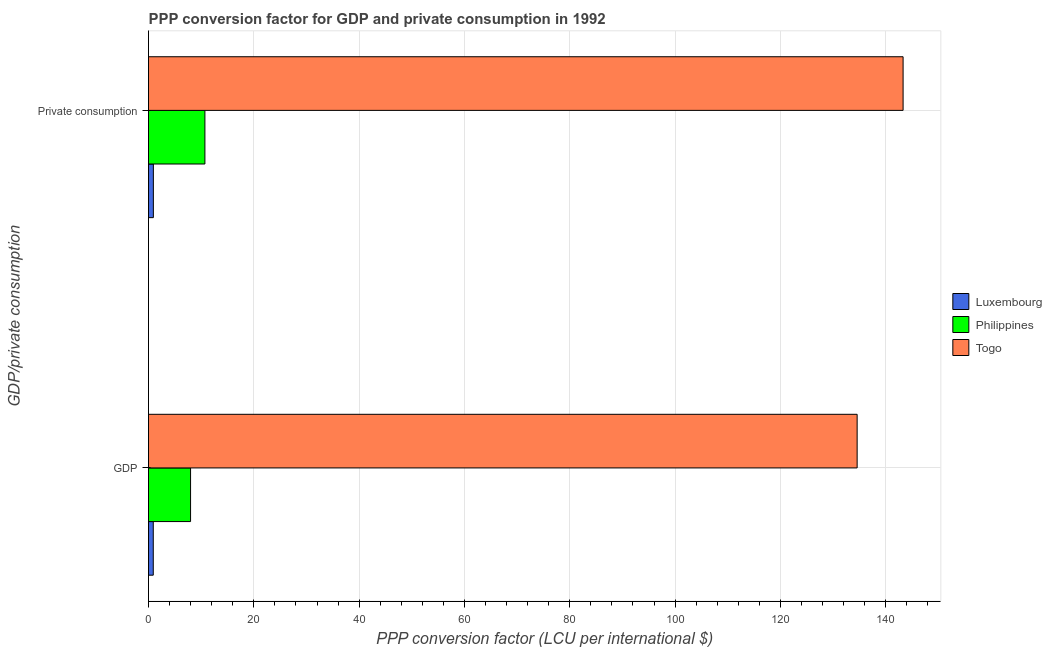How many different coloured bars are there?
Keep it short and to the point. 3. How many groups of bars are there?
Give a very brief answer. 2. Are the number of bars per tick equal to the number of legend labels?
Your response must be concise. Yes. How many bars are there on the 2nd tick from the top?
Your answer should be compact. 3. How many bars are there on the 2nd tick from the bottom?
Make the answer very short. 3. What is the label of the 2nd group of bars from the top?
Your response must be concise. GDP. What is the ppp conversion factor for gdp in Togo?
Keep it short and to the point. 134.57. Across all countries, what is the maximum ppp conversion factor for private consumption?
Make the answer very short. 143.3. Across all countries, what is the minimum ppp conversion factor for gdp?
Provide a short and direct response. 0.9. In which country was the ppp conversion factor for gdp maximum?
Offer a very short reply. Togo. In which country was the ppp conversion factor for gdp minimum?
Your answer should be very brief. Luxembourg. What is the total ppp conversion factor for gdp in the graph?
Ensure brevity in your answer.  143.46. What is the difference between the ppp conversion factor for gdp in Togo and that in Philippines?
Your answer should be compact. 126.59. What is the difference between the ppp conversion factor for gdp in Togo and the ppp conversion factor for private consumption in Philippines?
Keep it short and to the point. 123.86. What is the average ppp conversion factor for gdp per country?
Your answer should be very brief. 47.82. What is the difference between the ppp conversion factor for private consumption and ppp conversion factor for gdp in Philippines?
Give a very brief answer. 2.72. In how many countries, is the ppp conversion factor for private consumption greater than 52 LCU?
Ensure brevity in your answer.  1. What is the ratio of the ppp conversion factor for private consumption in Luxembourg to that in Togo?
Give a very brief answer. 0.01. What does the 1st bar from the top in  Private consumption represents?
Provide a short and direct response. Togo. What does the 1st bar from the bottom in  Private consumption represents?
Provide a short and direct response. Luxembourg. How many bars are there?
Your answer should be compact. 6. How many countries are there in the graph?
Your response must be concise. 3. What is the difference between two consecutive major ticks on the X-axis?
Make the answer very short. 20. Are the values on the major ticks of X-axis written in scientific E-notation?
Give a very brief answer. No. Where does the legend appear in the graph?
Offer a terse response. Center right. What is the title of the graph?
Your answer should be very brief. PPP conversion factor for GDP and private consumption in 1992. Does "Cuba" appear as one of the legend labels in the graph?
Make the answer very short. No. What is the label or title of the X-axis?
Offer a terse response. PPP conversion factor (LCU per international $). What is the label or title of the Y-axis?
Provide a short and direct response. GDP/private consumption. What is the PPP conversion factor (LCU per international $) in Luxembourg in GDP?
Provide a succinct answer. 0.9. What is the PPP conversion factor (LCU per international $) of Philippines in GDP?
Provide a succinct answer. 7.98. What is the PPP conversion factor (LCU per international $) of Togo in GDP?
Provide a short and direct response. 134.57. What is the PPP conversion factor (LCU per international $) of Luxembourg in  Private consumption?
Provide a succinct answer. 0.92. What is the PPP conversion factor (LCU per international $) of Philippines in  Private consumption?
Provide a short and direct response. 10.71. What is the PPP conversion factor (LCU per international $) of Togo in  Private consumption?
Ensure brevity in your answer.  143.3. Across all GDP/private consumption, what is the maximum PPP conversion factor (LCU per international $) in Luxembourg?
Provide a short and direct response. 0.92. Across all GDP/private consumption, what is the maximum PPP conversion factor (LCU per international $) in Philippines?
Keep it short and to the point. 10.71. Across all GDP/private consumption, what is the maximum PPP conversion factor (LCU per international $) of Togo?
Your answer should be compact. 143.3. Across all GDP/private consumption, what is the minimum PPP conversion factor (LCU per international $) in Luxembourg?
Ensure brevity in your answer.  0.9. Across all GDP/private consumption, what is the minimum PPP conversion factor (LCU per international $) in Philippines?
Offer a very short reply. 7.98. Across all GDP/private consumption, what is the minimum PPP conversion factor (LCU per international $) in Togo?
Your response must be concise. 134.57. What is the total PPP conversion factor (LCU per international $) in Luxembourg in the graph?
Offer a terse response. 1.82. What is the total PPP conversion factor (LCU per international $) in Philippines in the graph?
Offer a very short reply. 18.69. What is the total PPP conversion factor (LCU per international $) of Togo in the graph?
Your response must be concise. 277.87. What is the difference between the PPP conversion factor (LCU per international $) of Luxembourg in GDP and that in  Private consumption?
Your answer should be very brief. -0.02. What is the difference between the PPP conversion factor (LCU per international $) in Philippines in GDP and that in  Private consumption?
Offer a terse response. -2.72. What is the difference between the PPP conversion factor (LCU per international $) of Togo in GDP and that in  Private consumption?
Offer a very short reply. -8.73. What is the difference between the PPP conversion factor (LCU per international $) of Luxembourg in GDP and the PPP conversion factor (LCU per international $) of Philippines in  Private consumption?
Offer a very short reply. -9.81. What is the difference between the PPP conversion factor (LCU per international $) in Luxembourg in GDP and the PPP conversion factor (LCU per international $) in Togo in  Private consumption?
Ensure brevity in your answer.  -142.4. What is the difference between the PPP conversion factor (LCU per international $) of Philippines in GDP and the PPP conversion factor (LCU per international $) of Togo in  Private consumption?
Your response must be concise. -135.31. What is the average PPP conversion factor (LCU per international $) of Luxembourg per GDP/private consumption?
Keep it short and to the point. 0.91. What is the average PPP conversion factor (LCU per international $) of Philippines per GDP/private consumption?
Give a very brief answer. 9.35. What is the average PPP conversion factor (LCU per international $) of Togo per GDP/private consumption?
Ensure brevity in your answer.  138.93. What is the difference between the PPP conversion factor (LCU per international $) of Luxembourg and PPP conversion factor (LCU per international $) of Philippines in GDP?
Provide a short and direct response. -7.08. What is the difference between the PPP conversion factor (LCU per international $) in Luxembourg and PPP conversion factor (LCU per international $) in Togo in GDP?
Your response must be concise. -133.67. What is the difference between the PPP conversion factor (LCU per international $) of Philippines and PPP conversion factor (LCU per international $) of Togo in GDP?
Keep it short and to the point. -126.59. What is the difference between the PPP conversion factor (LCU per international $) in Luxembourg and PPP conversion factor (LCU per international $) in Philippines in  Private consumption?
Your response must be concise. -9.79. What is the difference between the PPP conversion factor (LCU per international $) in Luxembourg and PPP conversion factor (LCU per international $) in Togo in  Private consumption?
Your response must be concise. -142.38. What is the difference between the PPP conversion factor (LCU per international $) in Philippines and PPP conversion factor (LCU per international $) in Togo in  Private consumption?
Provide a short and direct response. -132.59. What is the ratio of the PPP conversion factor (LCU per international $) of Luxembourg in GDP to that in  Private consumption?
Give a very brief answer. 0.98. What is the ratio of the PPP conversion factor (LCU per international $) in Philippines in GDP to that in  Private consumption?
Make the answer very short. 0.75. What is the ratio of the PPP conversion factor (LCU per international $) in Togo in GDP to that in  Private consumption?
Make the answer very short. 0.94. What is the difference between the highest and the second highest PPP conversion factor (LCU per international $) in Luxembourg?
Keep it short and to the point. 0.02. What is the difference between the highest and the second highest PPP conversion factor (LCU per international $) in Philippines?
Your response must be concise. 2.72. What is the difference between the highest and the second highest PPP conversion factor (LCU per international $) in Togo?
Offer a very short reply. 8.73. What is the difference between the highest and the lowest PPP conversion factor (LCU per international $) in Luxembourg?
Your answer should be very brief. 0.02. What is the difference between the highest and the lowest PPP conversion factor (LCU per international $) in Philippines?
Give a very brief answer. 2.72. What is the difference between the highest and the lowest PPP conversion factor (LCU per international $) of Togo?
Make the answer very short. 8.73. 